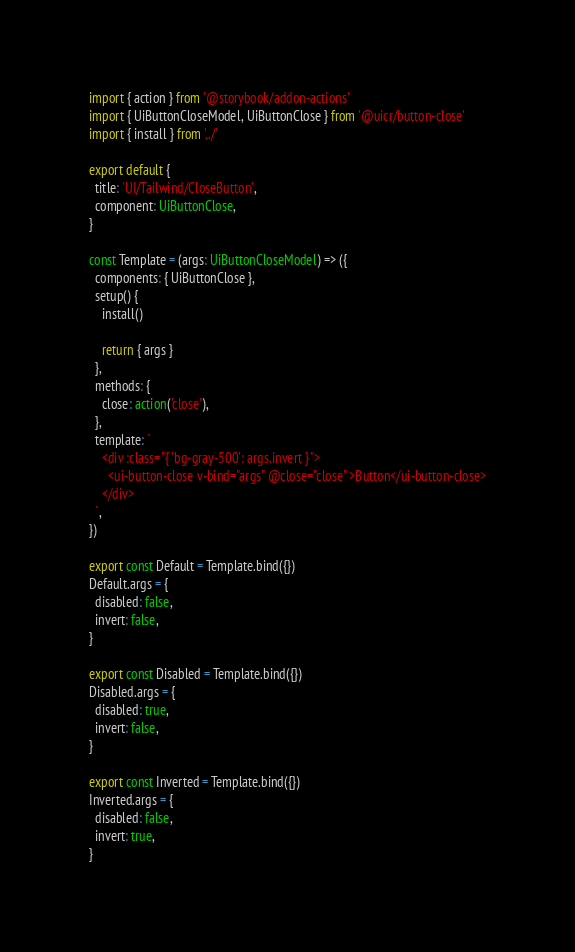<code> <loc_0><loc_0><loc_500><loc_500><_TypeScript_>import { action } from '@storybook/addon-actions'
import { UiButtonCloseModel, UiButtonClose } from '@uicr/button-close'
import { install } from '../'

export default {
  title: 'UI/Tailwind/CloseButton',
  component: UiButtonClose,
}

const Template = (args: UiButtonCloseModel) => ({
  components: { UiButtonClose },
  setup() {
    install()

    return { args }
  },
  methods: {
    close: action('close'),
  },
  template: `
    <div :class="{ 'bg-gray-500': args.invert }">
      <ui-button-close v-bind="args" @close="close" >Button</ui-button-close>
    </div>
  `,
})

export const Default = Template.bind({})
Default.args = {
  disabled: false,
  invert: false,
}

export const Disabled = Template.bind({})
Disabled.args = {
  disabled: true,
  invert: false,
}

export const Inverted = Template.bind({})
Inverted.args = {
  disabled: false,
  invert: true,
}
</code> 